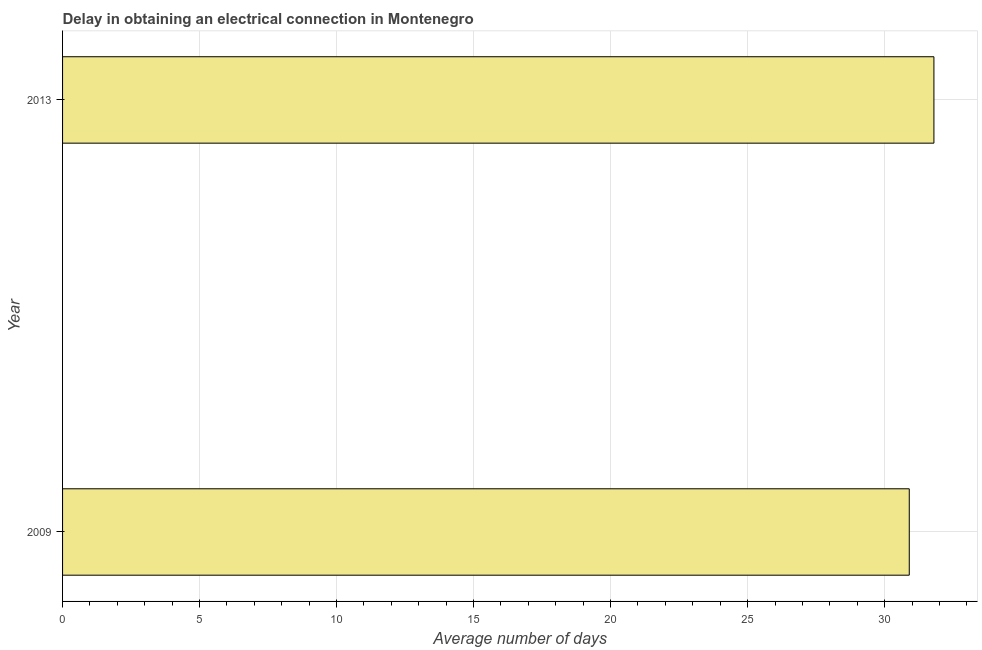Does the graph contain grids?
Your answer should be very brief. Yes. What is the title of the graph?
Ensure brevity in your answer.  Delay in obtaining an electrical connection in Montenegro. What is the label or title of the X-axis?
Your response must be concise. Average number of days. What is the label or title of the Y-axis?
Offer a very short reply. Year. What is the dalay in electrical connection in 2013?
Your response must be concise. 31.8. Across all years, what is the maximum dalay in electrical connection?
Provide a succinct answer. 31.8. Across all years, what is the minimum dalay in electrical connection?
Make the answer very short. 30.9. In which year was the dalay in electrical connection maximum?
Offer a terse response. 2013. In which year was the dalay in electrical connection minimum?
Offer a very short reply. 2009. What is the sum of the dalay in electrical connection?
Ensure brevity in your answer.  62.7. What is the average dalay in electrical connection per year?
Provide a short and direct response. 31.35. What is the median dalay in electrical connection?
Offer a terse response. 31.35. Do a majority of the years between 2009 and 2013 (inclusive) have dalay in electrical connection greater than 10 days?
Provide a short and direct response. Yes. What is the ratio of the dalay in electrical connection in 2009 to that in 2013?
Give a very brief answer. 0.97. How many years are there in the graph?
Your answer should be very brief. 2. Are the values on the major ticks of X-axis written in scientific E-notation?
Provide a short and direct response. No. What is the Average number of days in 2009?
Provide a short and direct response. 30.9. What is the Average number of days in 2013?
Keep it short and to the point. 31.8. What is the difference between the Average number of days in 2009 and 2013?
Provide a succinct answer. -0.9. What is the ratio of the Average number of days in 2009 to that in 2013?
Your answer should be very brief. 0.97. 